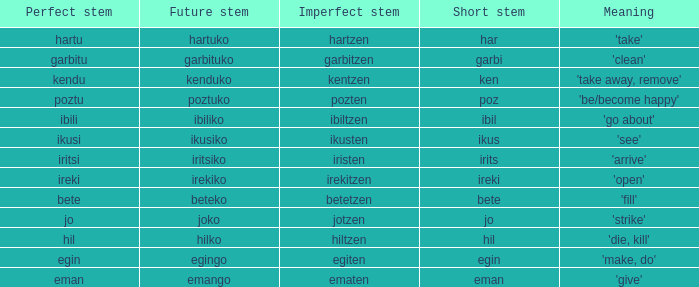What is the number for future stem for poztu? 1.0. 